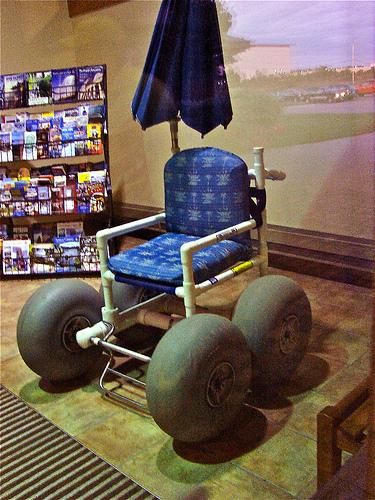Is this chair padded?
Concise answer only. Yes. Do you see an umbrella?
Concise answer only. Yes. Do the wheels on this chair look normal?
Answer briefly. No. 